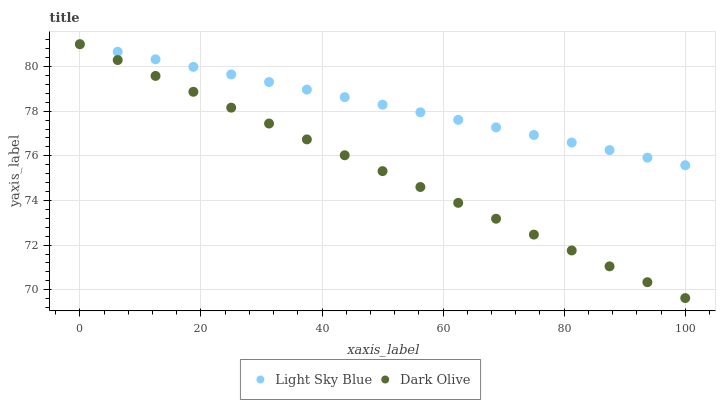Does Dark Olive have the minimum area under the curve?
Answer yes or no. Yes. Does Light Sky Blue have the maximum area under the curve?
Answer yes or no. Yes. Does Light Sky Blue have the minimum area under the curve?
Answer yes or no. No. Is Dark Olive the smoothest?
Answer yes or no. Yes. Is Light Sky Blue the roughest?
Answer yes or no. Yes. Is Light Sky Blue the smoothest?
Answer yes or no. No. Does Dark Olive have the lowest value?
Answer yes or no. Yes. Does Light Sky Blue have the lowest value?
Answer yes or no. No. Does Light Sky Blue have the highest value?
Answer yes or no. Yes. Does Light Sky Blue intersect Dark Olive?
Answer yes or no. Yes. Is Light Sky Blue less than Dark Olive?
Answer yes or no. No. Is Light Sky Blue greater than Dark Olive?
Answer yes or no. No. 